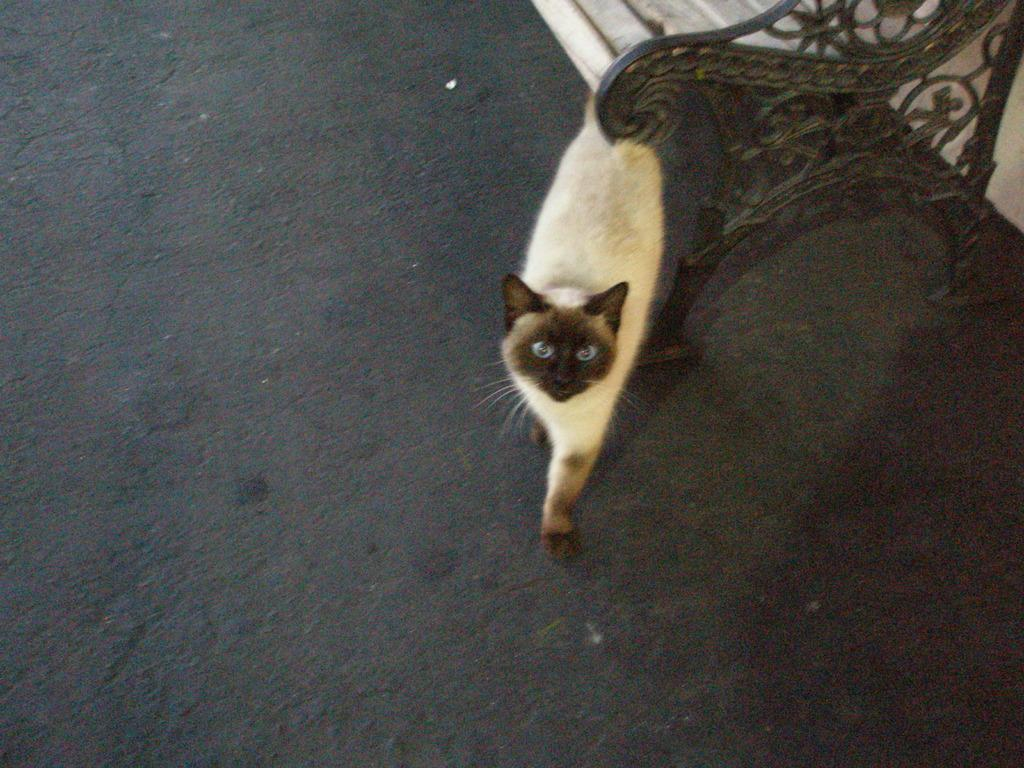What type of animal is in the image? There is a cat in the image. Can you describe the color pattern of the cat? The cat has a white and black color pattern. What is located in the top right of the image? There is a bench in the top right of the image. What type of fiction is the cat reading on the bench in the image? There is no fiction or book present in the image; it only features a cat and a bench. What type of beef is the cat eating in the image? There is no beef or food present in the image; it only features a cat and a bench. 